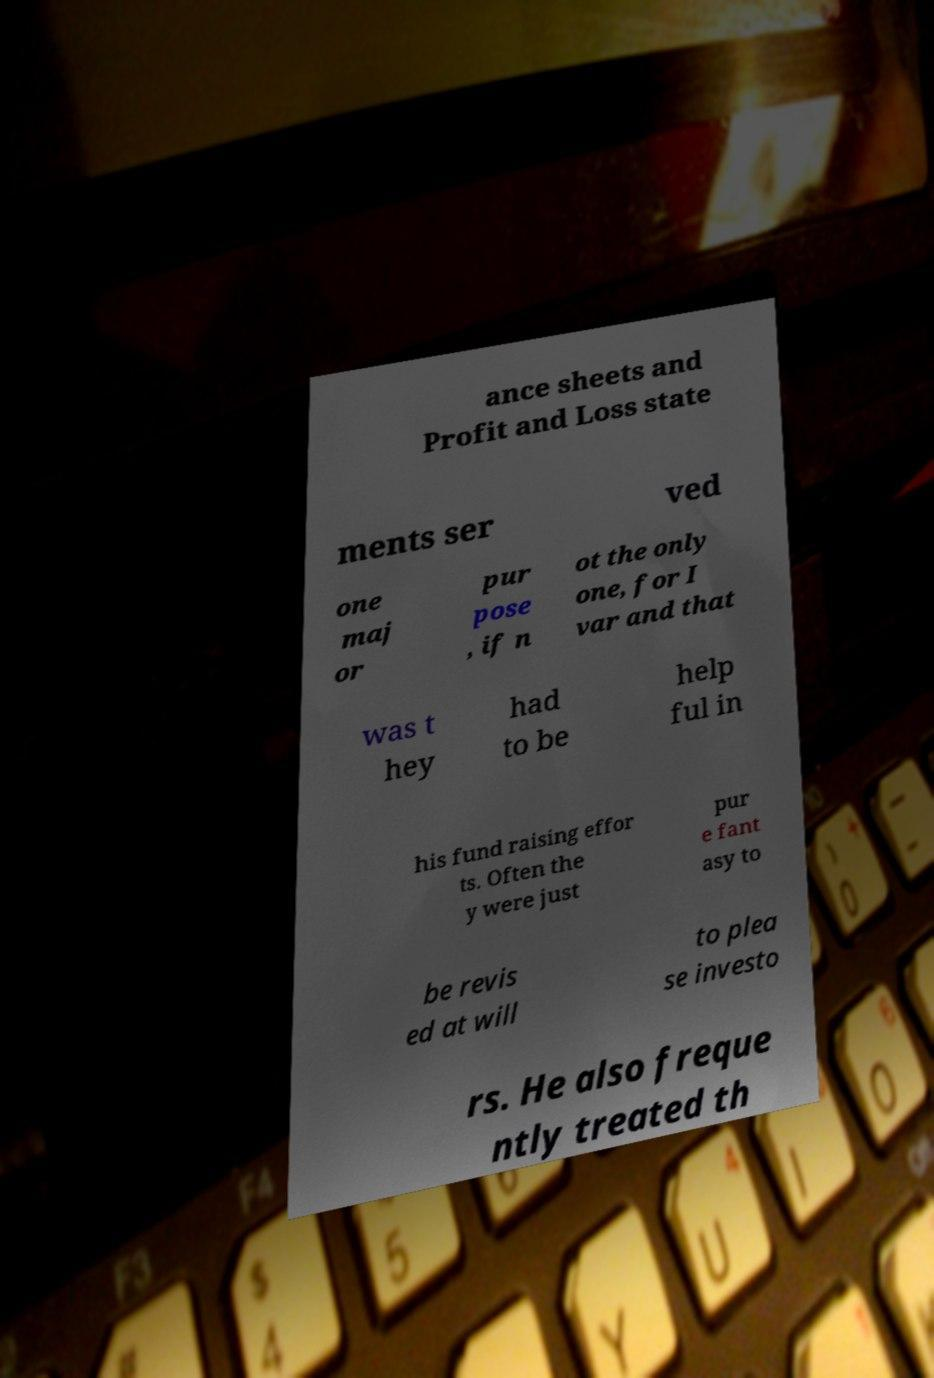There's text embedded in this image that I need extracted. Can you transcribe it verbatim? ance sheets and Profit and Loss state ments ser ved one maj or pur pose , if n ot the only one, for I var and that was t hey had to be help ful in his fund raising effor ts. Often the y were just pur e fant asy to be revis ed at will to plea se investo rs. He also freque ntly treated th 